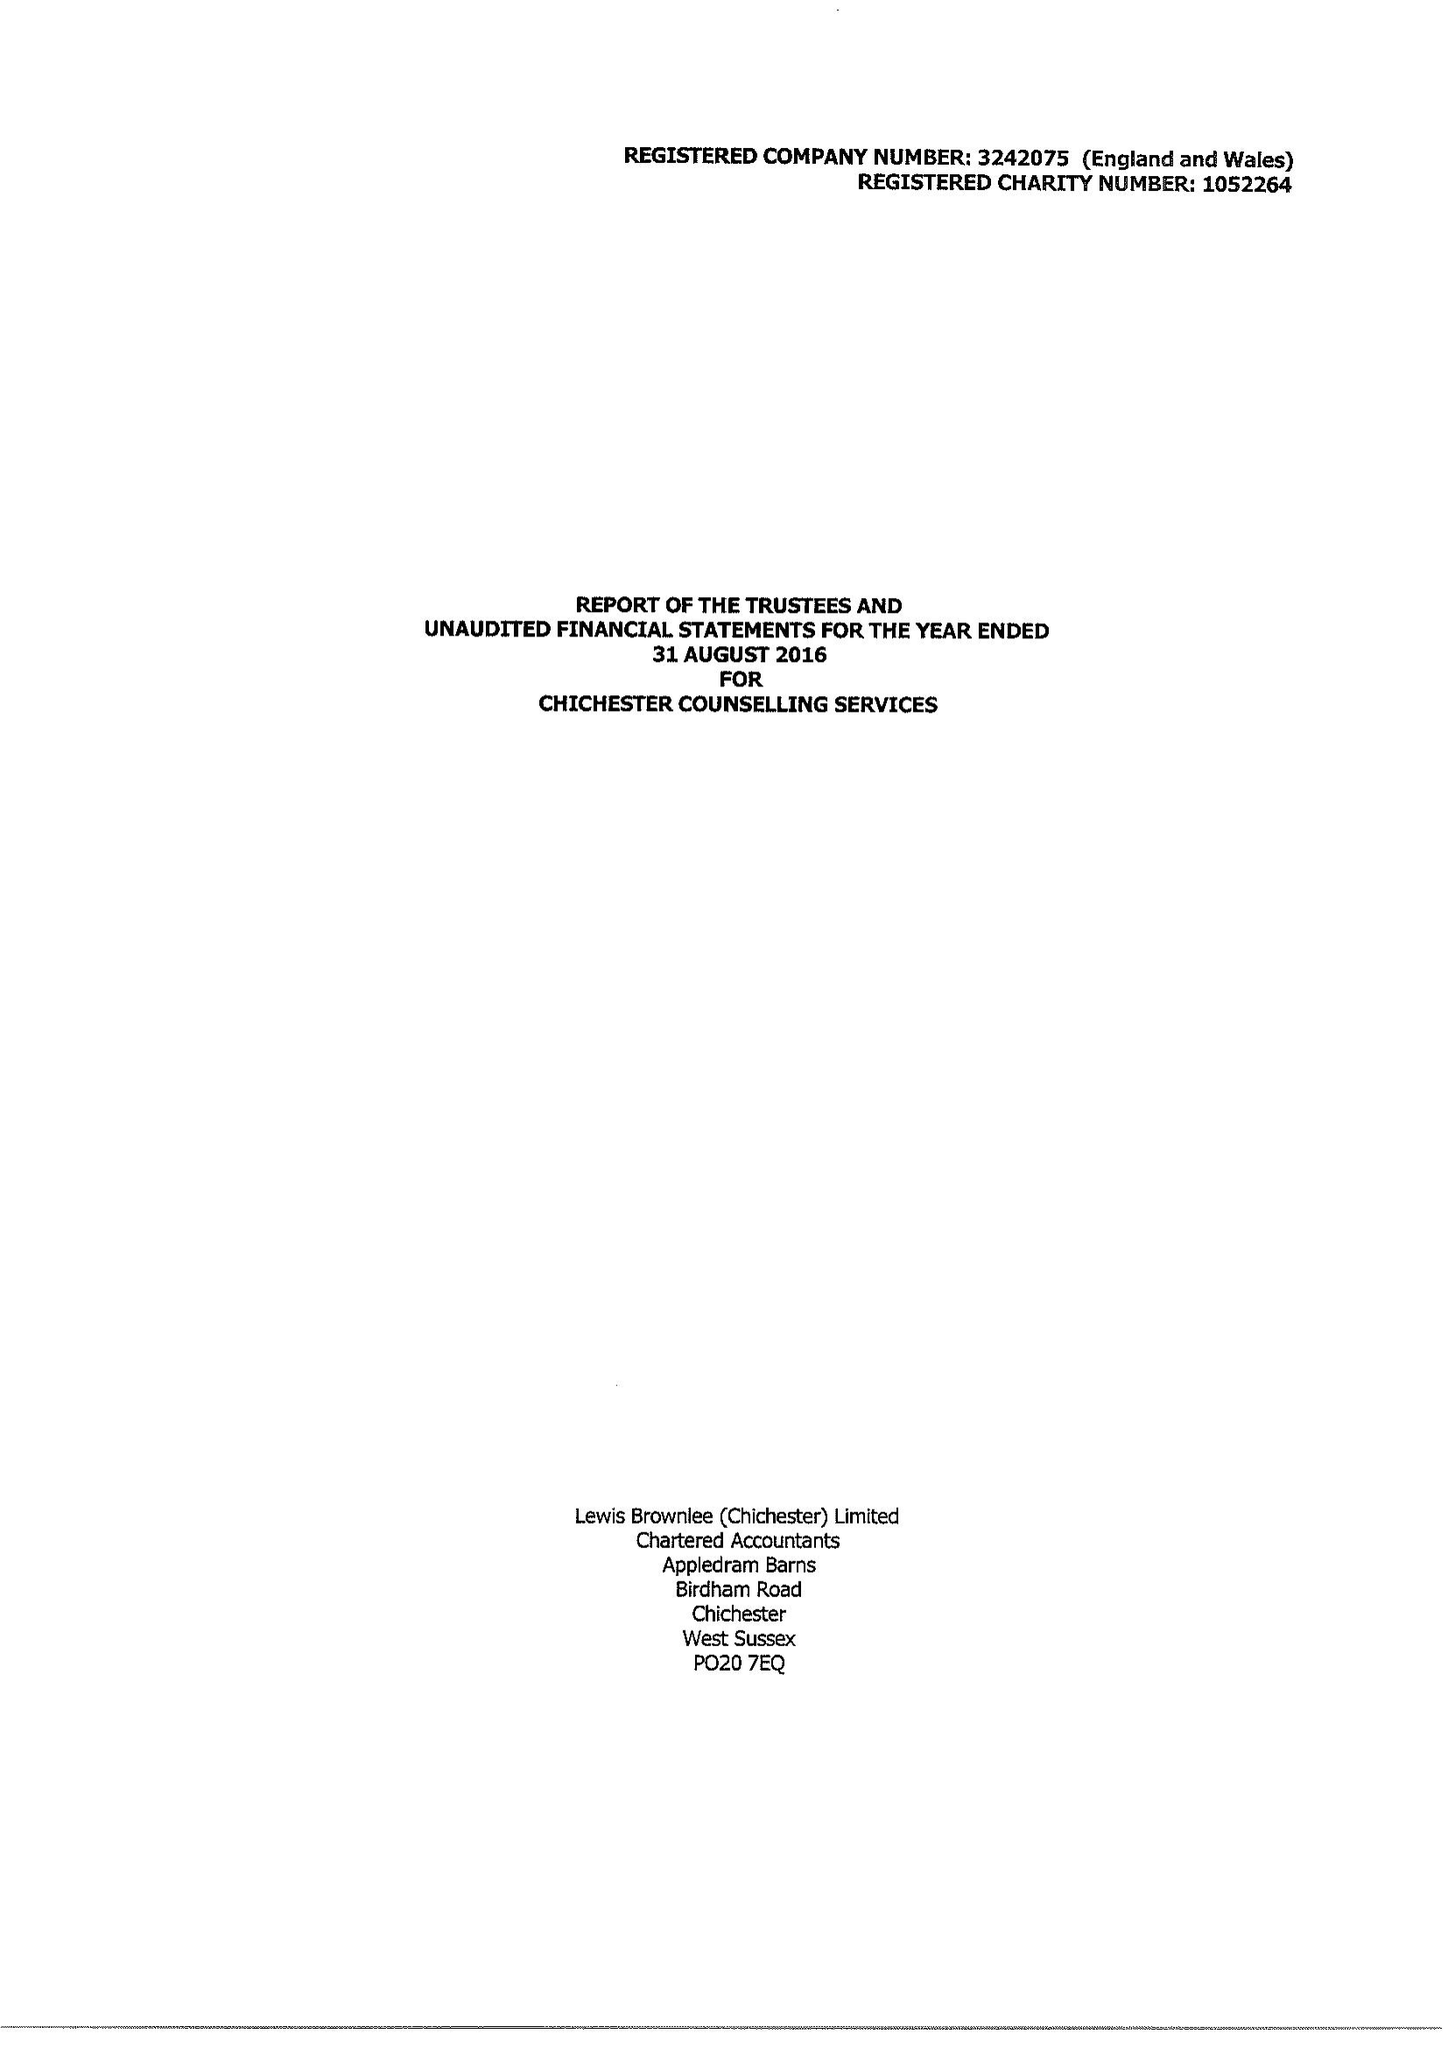What is the value for the charity_number?
Answer the question using a single word or phrase. 1052264 